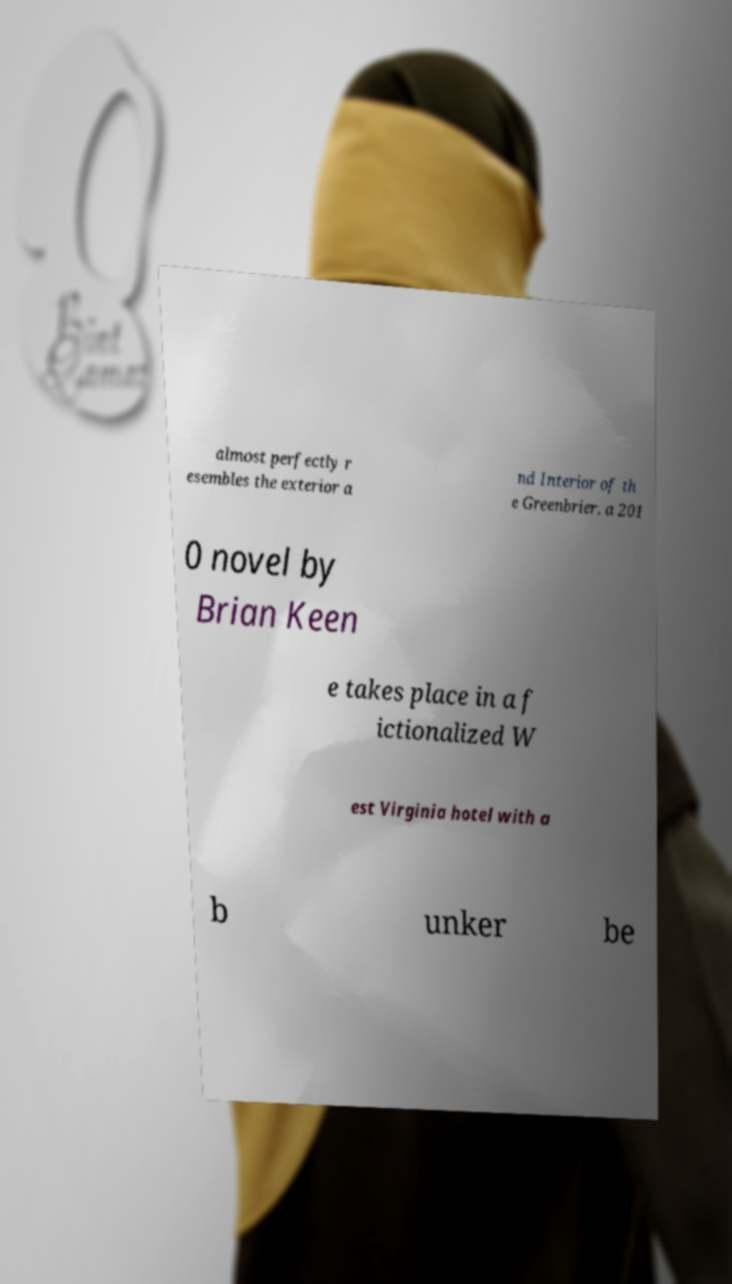Could you extract and type out the text from this image? almost perfectly r esembles the exterior a nd Interior of th e Greenbrier. a 201 0 novel by Brian Keen e takes place in a f ictionalized W est Virginia hotel with a b unker be 